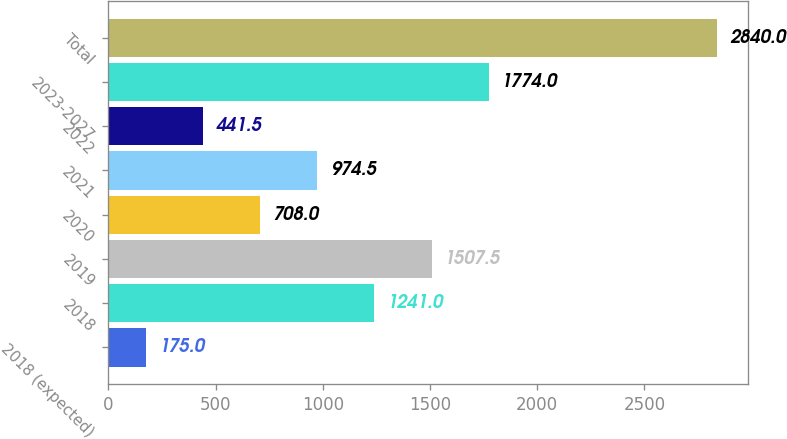<chart> <loc_0><loc_0><loc_500><loc_500><bar_chart><fcel>2018 (expected)<fcel>2018<fcel>2019<fcel>2020<fcel>2021<fcel>2022<fcel>2023-2027<fcel>Total<nl><fcel>175<fcel>1241<fcel>1507.5<fcel>708<fcel>974.5<fcel>441.5<fcel>1774<fcel>2840<nl></chart> 